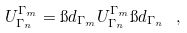<formula> <loc_0><loc_0><loc_500><loc_500>U ^ { \Gamma _ { m } } _ { \Gamma _ { n } } = \i d _ { \Gamma _ { m } } U ^ { \Gamma _ { m } } _ { \Gamma _ { n } } \i d _ { \Gamma _ { n } } \ ,</formula> 